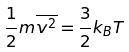<formula> <loc_0><loc_0><loc_500><loc_500>\frac { 1 } { 2 } m \overline { v ^ { 2 } } = \frac { 3 } { 2 } k _ { B } T</formula> 